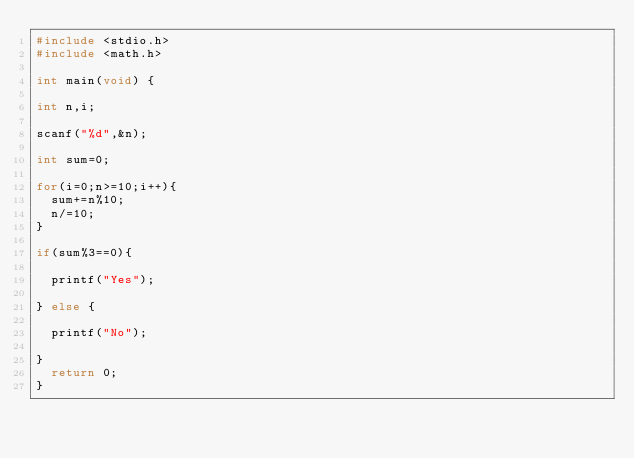Convert code to text. <code><loc_0><loc_0><loc_500><loc_500><_C_>#include <stdio.h>
#include <math.h>

int main(void) {
 
int n,i;

scanf("%d",&n);

int sum=0;

for(i=0;n>=10;i++){
  sum+=n%10;
  n/=10;
}

if(sum%3==0){

  printf("Yes");

} else {

  printf("No");

}
  return 0;
}</code> 